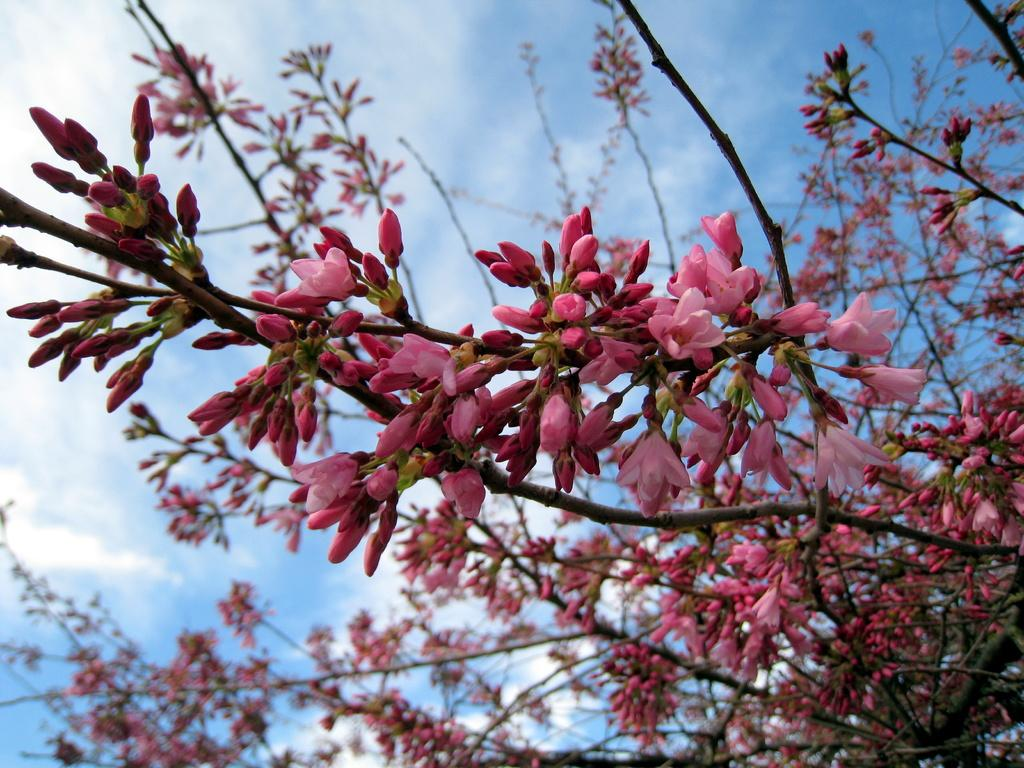What type of flowers can be seen in the image? There are pink color flowers in the image. What stage of growth are some of the flowers in? There are buds in the image. What part of the natural environment is visible in the image? The sky is visible in the image. How would you describe the weather based on the sky? The sky appears to be cloudy in the image. How many girls are sitting on the boat in the image? There are no girls or boats present in the image; it features pink color flowers and a cloudy sky. 